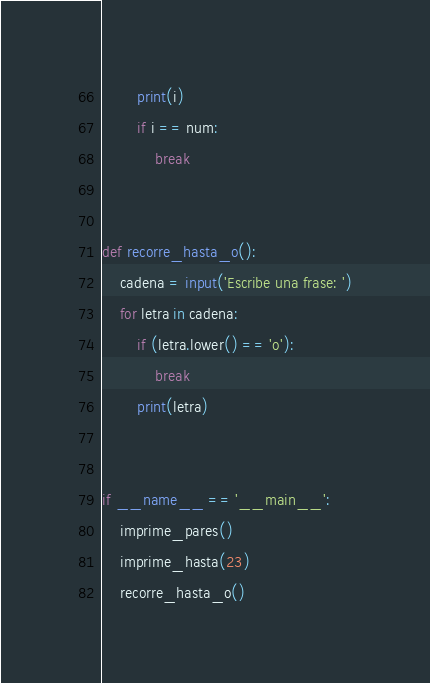Convert code to text. <code><loc_0><loc_0><loc_500><loc_500><_Python_>        print(i)
        if i == num:
            break


def recorre_hasta_o():
    cadena = input('Escribe una frase: ')
    for letra in cadena:
        if (letra.lower() == 'o'):
            break
        print(letra)


if __name__ == '__main__':
    imprime_pares()
    imprime_hasta(23)
    recorre_hasta_o()
</code> 